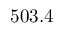Convert formula to latex. <formula><loc_0><loc_0><loc_500><loc_500>5 0 3 . 4</formula> 